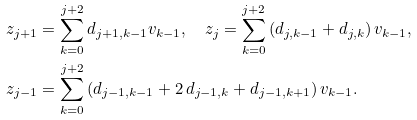Convert formula to latex. <formula><loc_0><loc_0><loc_500><loc_500>z _ { j + 1 } & = \sum _ { k = 0 } ^ { j + 2 } d _ { j + 1 , k - 1 } v _ { k - 1 } , \quad z _ { j } = \sum _ { k = 0 } ^ { j + 2 } \left ( d _ { j , k - 1 } + d _ { j , k } \right ) v _ { k - 1 } , \\ z _ { j - 1 } & = \sum _ { k = 0 } ^ { j + 2 } \left ( d _ { j - 1 , k - 1 } + 2 \, d _ { j - 1 , k } + d _ { j - 1 , k + 1 } \right ) v _ { k - 1 } .</formula> 